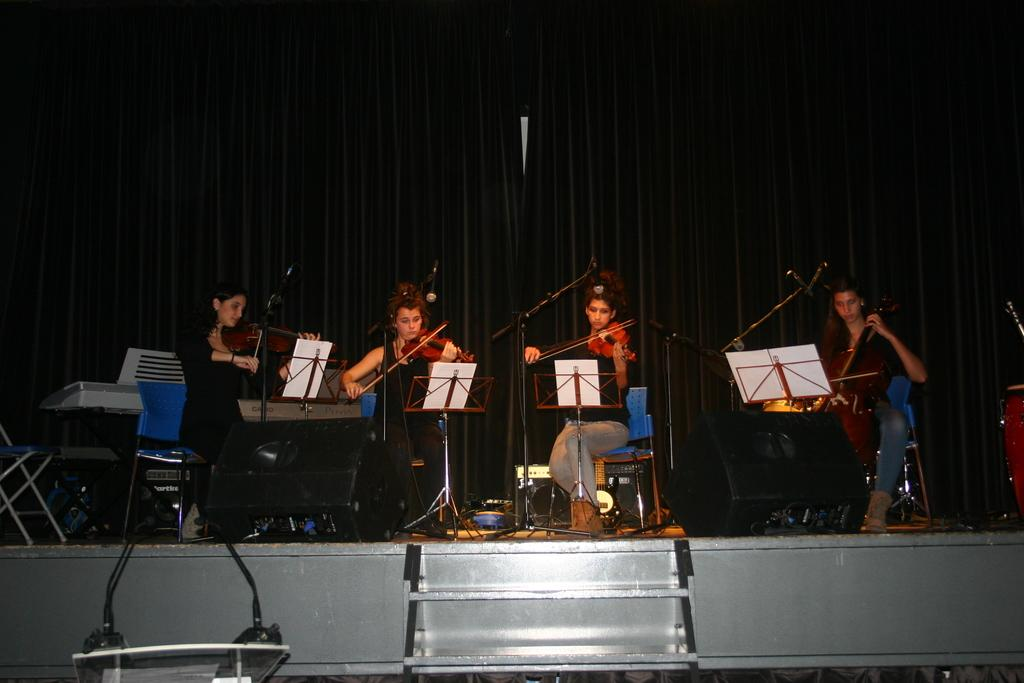How many persons are in the image? There is a group of persons in the image. What are the persons doing in the image? The persons are sitting on chairs. Can you identify any musical activity in the image? Yes, at least one person is playing a violin. What else can be seen in the image besides the persons and chairs? There is a book and a staircase in the image. What type of picture is hanging on the wall in the image? There is no mention of a picture hanging on the wall in the image; the facts provided do not include any information about a wall or a picture. 